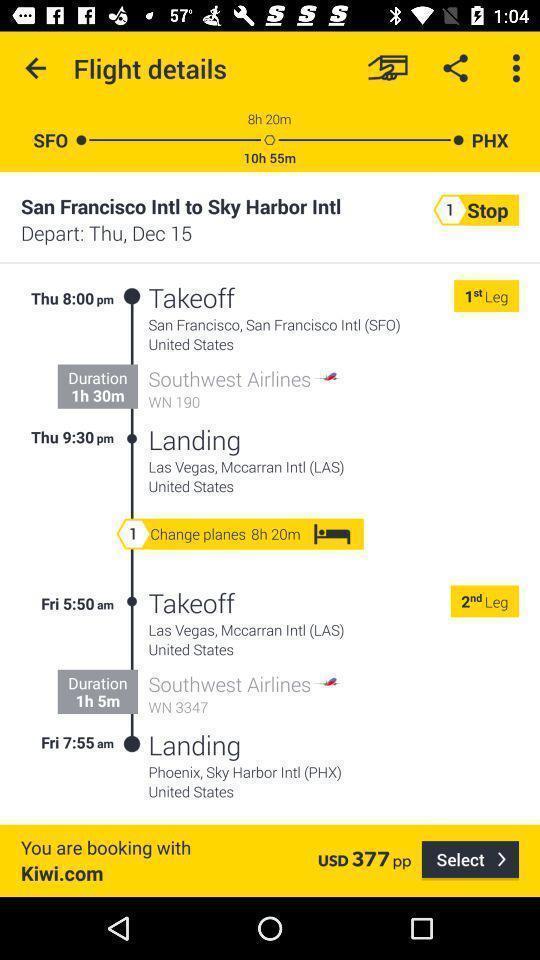Summarize the main components in this picture. Page showing the details of the flight. 